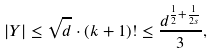Convert formula to latex. <formula><loc_0><loc_0><loc_500><loc_500>| Y | \leq \sqrt { d } \cdot ( k + 1 ) ! \leq \frac { d ^ { \frac { 1 } { 2 } + \frac { 1 } { 2 s } } } { 3 } ,</formula> 